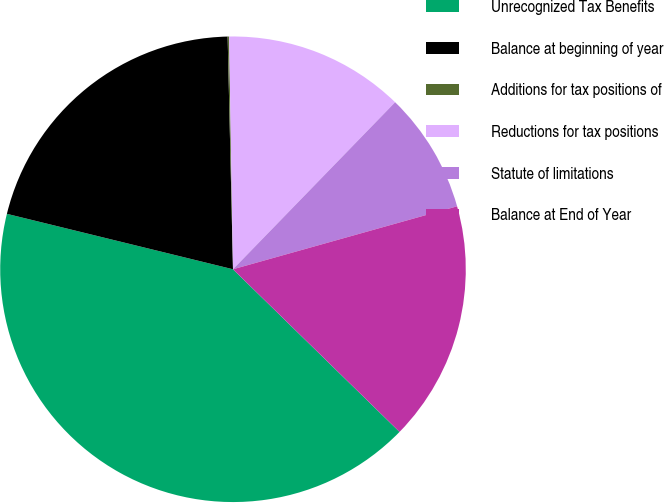Convert chart to OTSL. <chart><loc_0><loc_0><loc_500><loc_500><pie_chart><fcel>Unrecognized Tax Benefits<fcel>Balance at beginning of year<fcel>Additions for tax positions of<fcel>Reductions for tax positions<fcel>Statute of limitations<fcel>Balance at End of Year<nl><fcel>41.52%<fcel>20.81%<fcel>0.1%<fcel>12.53%<fcel>8.38%<fcel>16.67%<nl></chart> 